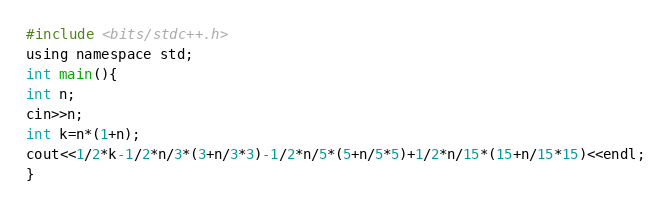Convert code to text. <code><loc_0><loc_0><loc_500><loc_500><_C_>#include <bits/stdc++.h>
using namespace std;
int main(){
int n;
cin>>n;
int k=n*(1+n);
cout<<1/2*k-1/2*n/3*(3+n/3*3)-1/2*n/5*(5+n/5*5)+1/2*n/15*(15+n/15*15)<<endl;
}</code> 